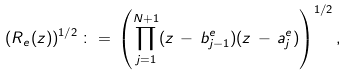<formula> <loc_0><loc_0><loc_500><loc_500>( R _ { e } ( z ) ) ^ { 1 / 2 } \, \colon = \, \left ( \prod _ { j = 1 } ^ { N + 1 } ( z \, - \, b _ { j - 1 } ^ { e } ) ( z \, - \, a _ { j } ^ { e } ) \right ) ^ { 1 / 2 } ,</formula> 